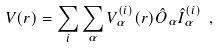Convert formula to latex. <formula><loc_0><loc_0><loc_500><loc_500>V ( { r } ) = \sum _ { i } \sum _ { \alpha } V _ { \alpha } ^ { ( i ) } ( r ) \hat { O } _ { \alpha } \hat { I } _ { \alpha } ^ { ( i ) } \ ,</formula> 